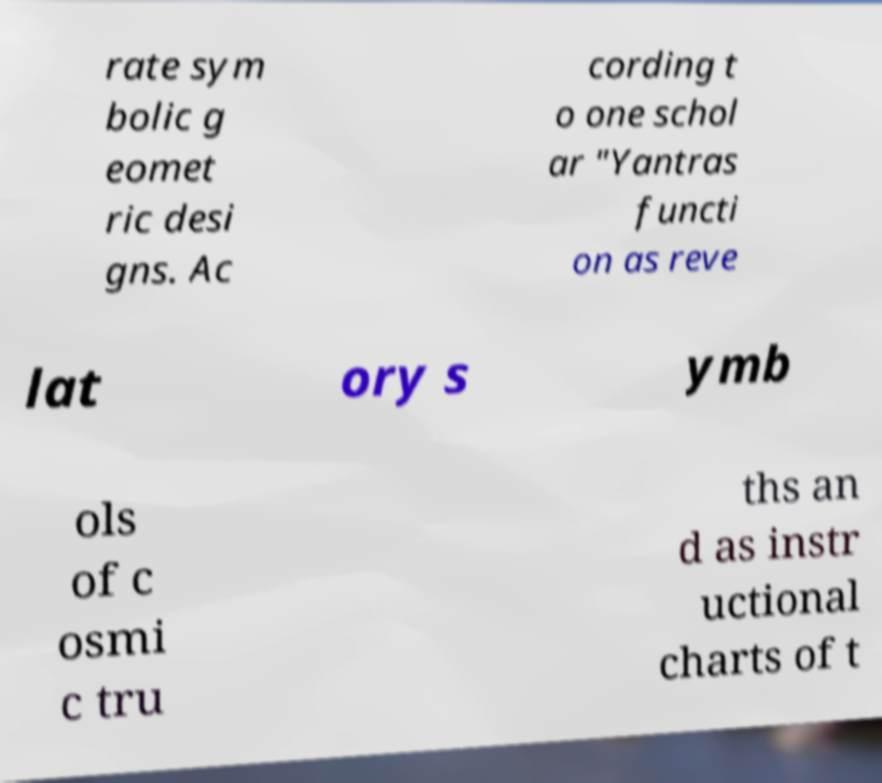For documentation purposes, I need the text within this image transcribed. Could you provide that? rate sym bolic g eomet ric desi gns. Ac cording t o one schol ar "Yantras functi on as reve lat ory s ymb ols of c osmi c tru ths an d as instr uctional charts of t 